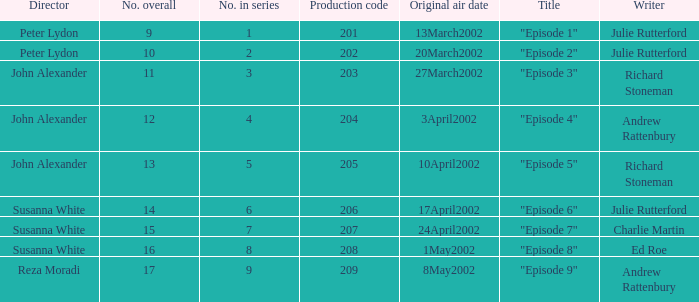When "episode 1" is the title what is the overall number? 9.0. 